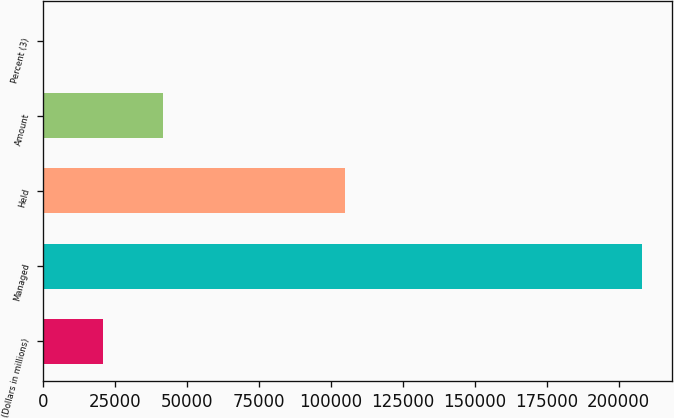Convert chart to OTSL. <chart><loc_0><loc_0><loc_500><loc_500><bar_chart><fcel>(Dollars in millions)<fcel>Managed<fcel>Held<fcel>Amount<fcel>Percent (3)<nl><fcel>20813.8<fcel>208094<fcel>104810<fcel>41622.7<fcel>4.85<nl></chart> 